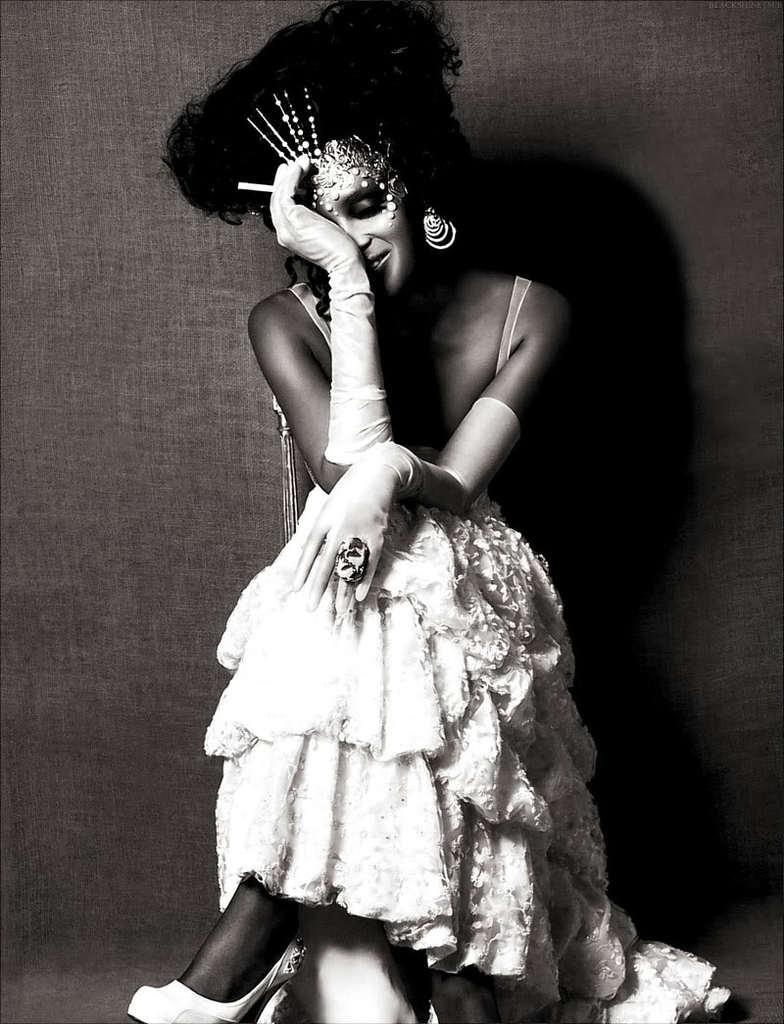What is the lady in the image doing? The lady is sitting in the image. What is the lady wearing on her hands? The lady is wearing gloves. What object is the lady holding in the image? The lady is holding a cigarette. What can be seen in the background of the image? There is a wall in the background of the image. What is the color scheme of the image? The image is black and white. What type of bells can be heard ringing in the image? There are no bells present in the image, and therefore no sound can be heard. 